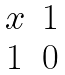Convert formula to latex. <formula><loc_0><loc_0><loc_500><loc_500>\begin{matrix} x & 1 \\ 1 & 0 \end{matrix}</formula> 